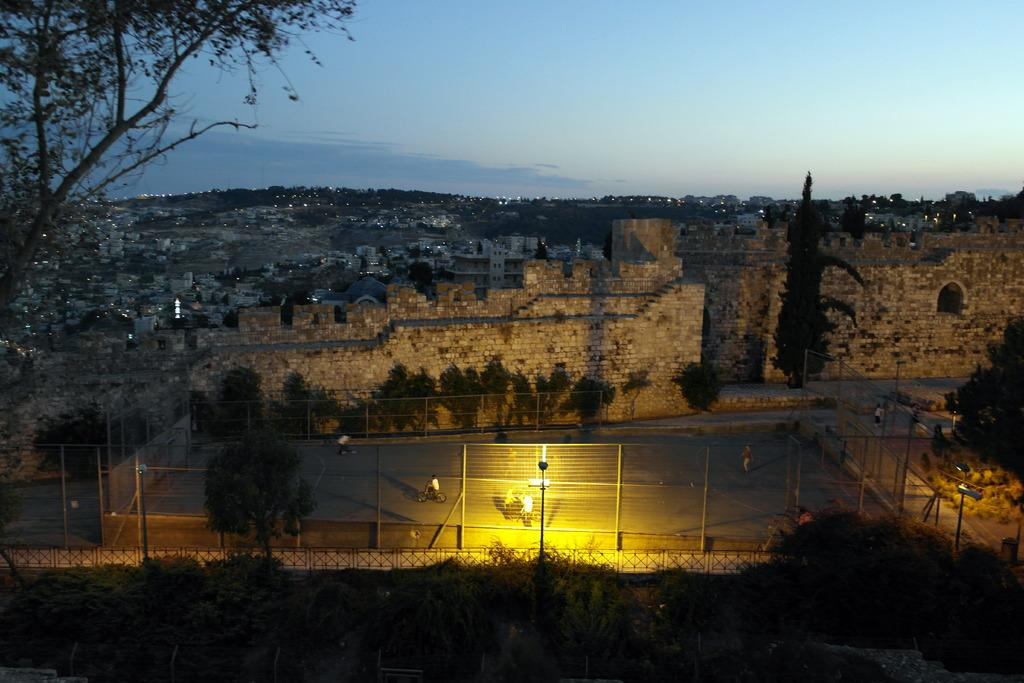What are the people in the image doing? The people in the image are riding bicycles. Can you describe the mesh in the image? There is a mesh in the image, but its purpose or specific details are not mentioned in the facts. What can be seen in the background of the image? In the background of the image, there are trees, buildings, hills, and the sky. What other structure is present in the image besides the bicycles? There is a fort in the image. What else can be seen in the image besides the people and the fort? There are lights in the image. What type of quiver is being used by the people riding bicycles in the image? There is no mention of a quiver in the image, as the people are riding bicycles and not using any archery equipment. Can you tell me how many notebooks are visible in the image? There is no mention of notebooks in the image, so it is impossible to determine their presence or quantity. 